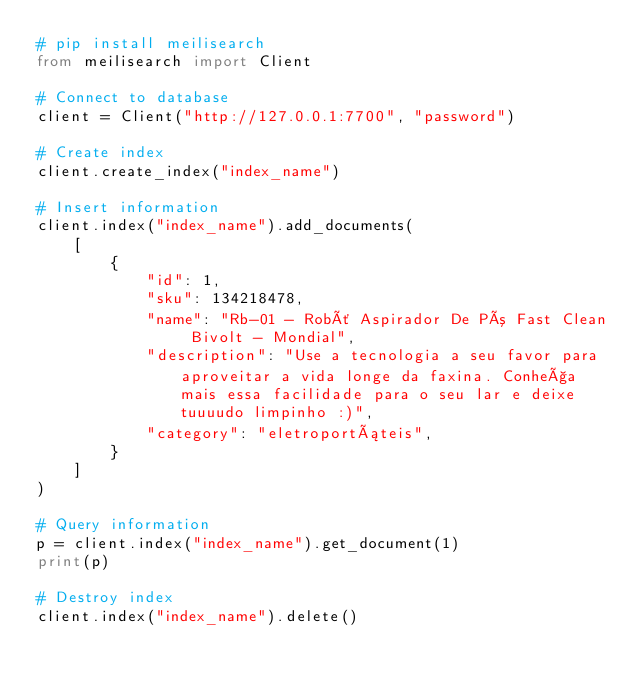Convert code to text. <code><loc_0><loc_0><loc_500><loc_500><_Python_># pip install meilisearch
from meilisearch import Client

# Connect to database
client = Client("http://127.0.0.1:7700", "password")

# Create index
client.create_index("index_name")

# Insert information
client.index("index_name").add_documents(
    [
        {
            "id": 1,
            "sku": 134218478,
            "name": "Rb-01 - Robô Aspirador De Pó Fast Clean Bivolt - Mondial",
            "description": "Use a tecnologia a seu favor para aproveitar a vida longe da faxina. Conheça mais essa facilidade para o seu lar e deixe tuuuudo limpinho :)",
            "category": "eletroportáteis",
        }
    ]
)

# Query information
p = client.index("index_name").get_document(1)
print(p)

# Destroy index
client.index("index_name").delete()
</code> 